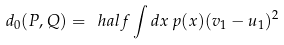Convert formula to latex. <formula><loc_0><loc_0><loc_500><loc_500>d _ { 0 } ( P , Q ) = \ h a l f \int { d } x \, p ( x ) ( v _ { 1 } - u _ { 1 } ) ^ { 2 }</formula> 